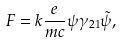<formula> <loc_0><loc_0><loc_500><loc_500>F = k \frac { e } { m c } \psi \gamma _ { 2 1 } \tilde { \psi } ,</formula> 